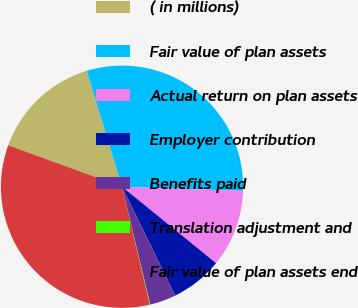Convert chart. <chart><loc_0><loc_0><loc_500><loc_500><pie_chart><fcel>( in millions)<fcel>Fair value of plan assets<fcel>Actual return on plan assets<fcel>Employer contribution<fcel>Benefits paid<fcel>Translation adjustment and<fcel>Fair value of plan assets end<nl><fcel>14.73%<fcel>30.25%<fcel>10.32%<fcel>6.9%<fcel>3.49%<fcel>0.07%<fcel>34.23%<nl></chart> 